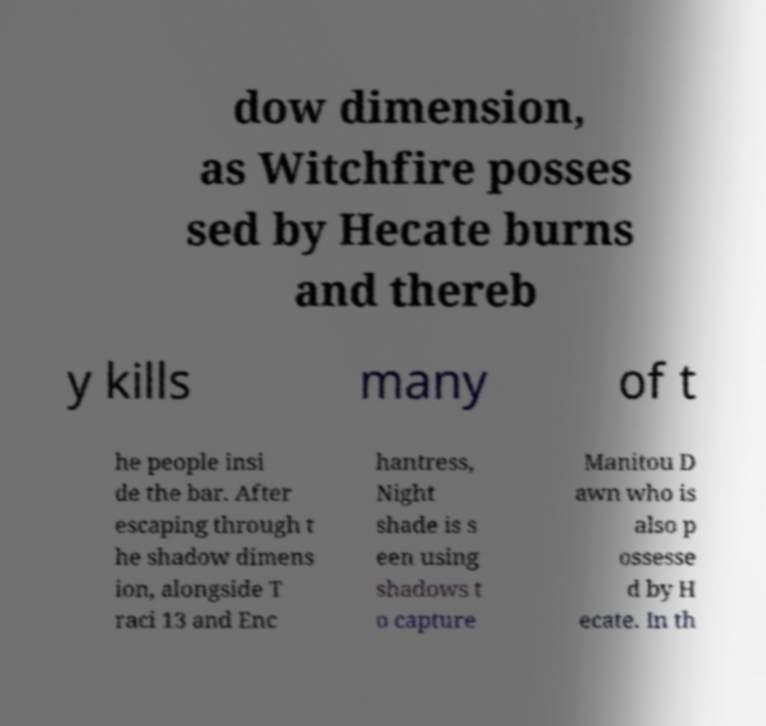Could you extract and type out the text from this image? dow dimension, as Witchfire posses sed by Hecate burns and thereb y kills many of t he people insi de the bar. After escaping through t he shadow dimens ion, alongside T raci 13 and Enc hantress, Night shade is s een using shadows t o capture Manitou D awn who is also p ossesse d by H ecate. In th 